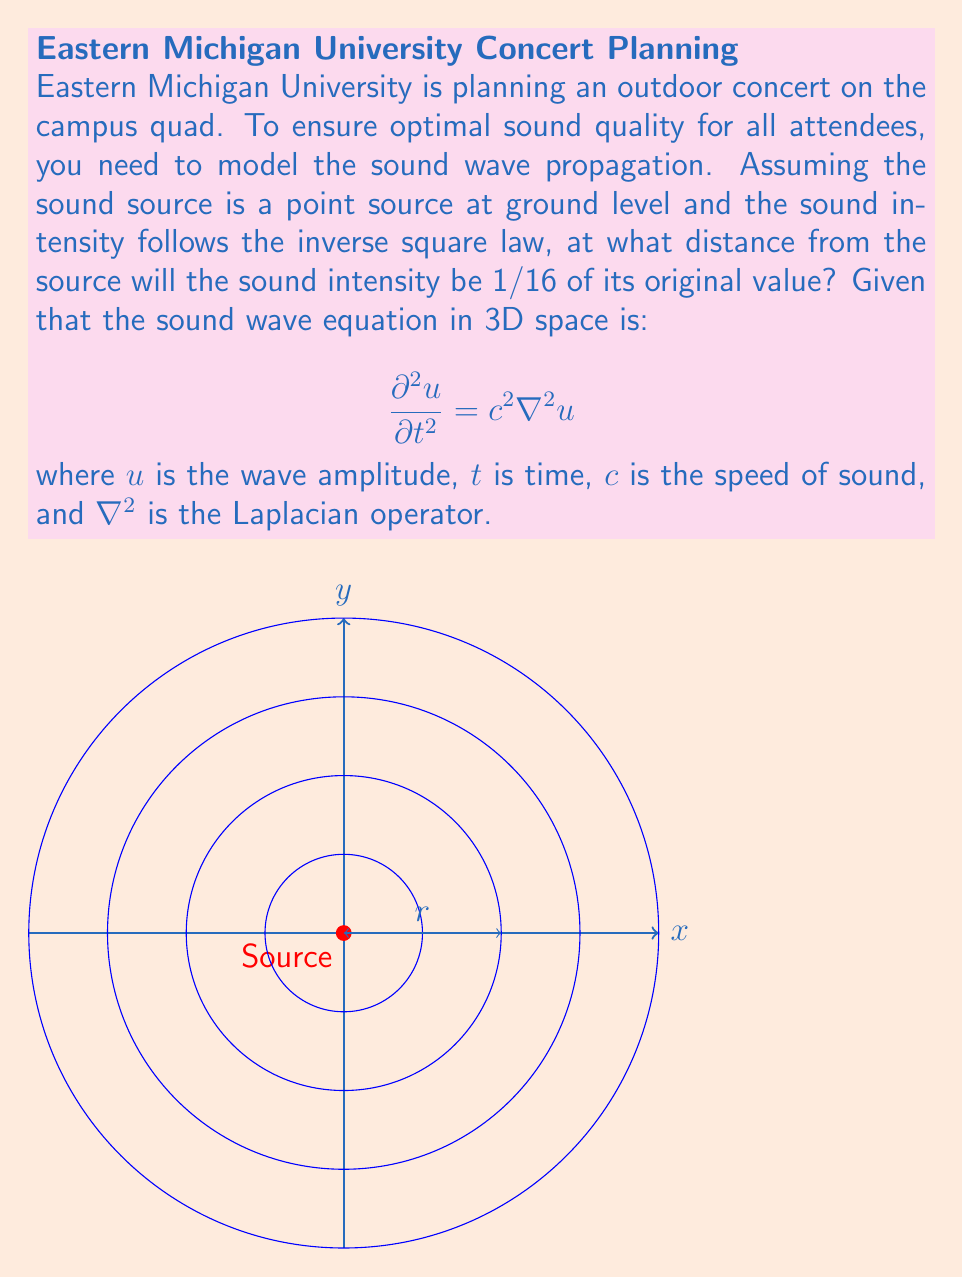Can you solve this math problem? To solve this problem, we'll follow these steps:

1) The inverse square law for sound intensity states that the intensity $I$ is inversely proportional to the square of the distance $r$ from the source:

   $$I \propto \frac{1}{r^2}$$

2) Let $I_0$ be the original intensity at the source, and $I$ be the intensity at distance $r$. We can write:

   $$I = \frac{I_0}{r^2}$$

3) We're told that at the distance we're looking for, the intensity will be 1/16 of the original. So:

   $$\frac{I}{I_0} = \frac{1}{16}$$

4) Substituting this into our equation:

   $$\frac{1}{16} = \frac{1}{r^2}$$

5) Solving for $r$:

   $$r^2 = 16$$
   $$r = \sqrt{16} = 4$$

6) Therefore, the distance at which the intensity will be 1/16 of the original is 4 units from the source.

Note: While the wave equation provided in the question is not directly used in solving this specific problem, it's relevant to understanding how sound waves propagate in 3D space. The solution we found using the inverse square law is consistent with the behavior described by this wave equation for a point source in free space.
Answer: 4 units 